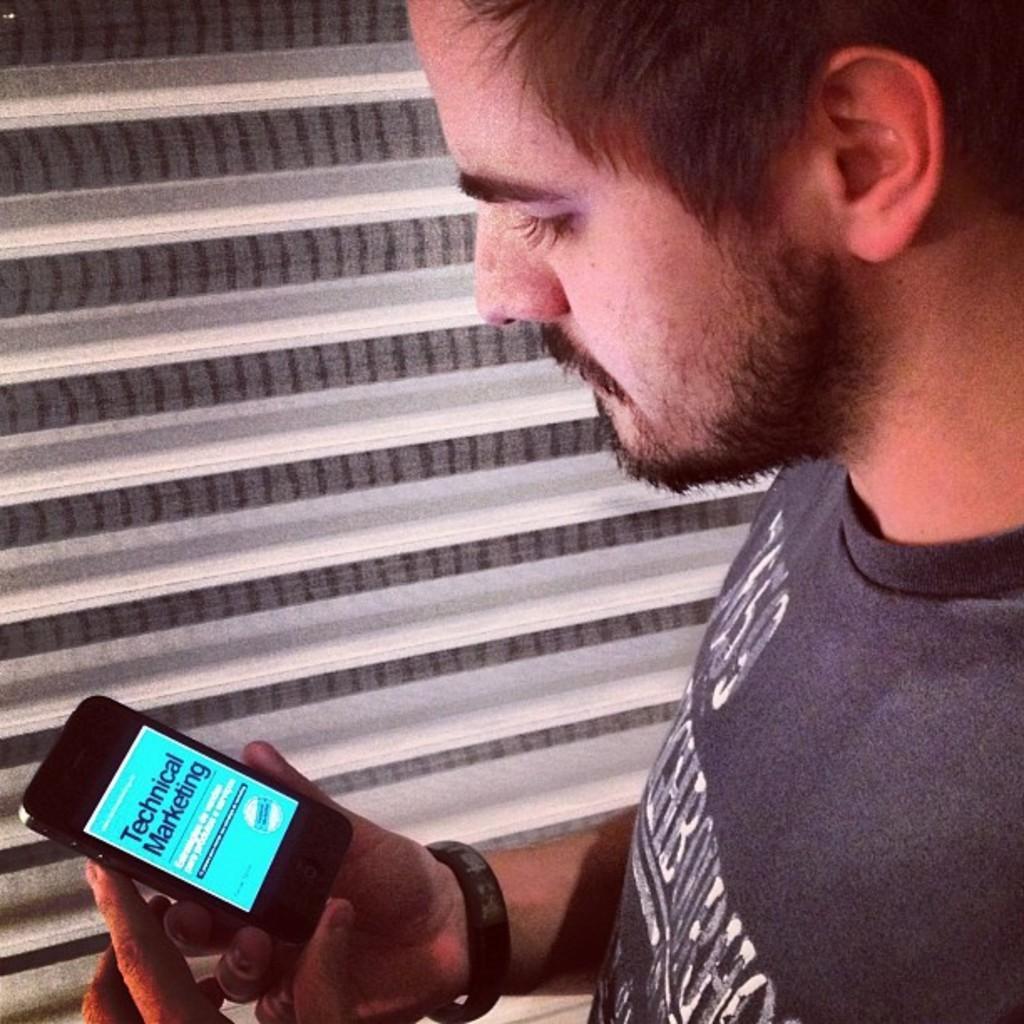Can you describe this image briefly? In this picture we can see a man holding a mobile in his hand. He wore a wristband to his hand. 